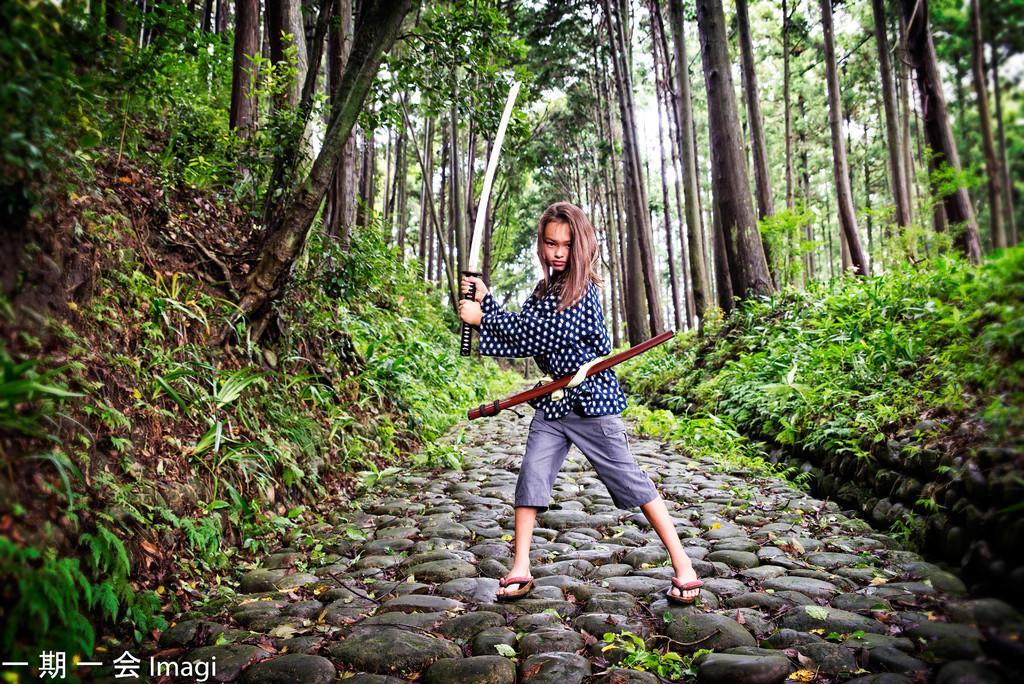Could you give a brief overview of what you see in this image? In the image we can see there is a kid standing and holding sword in her hand. Behind there are lot of trees. 